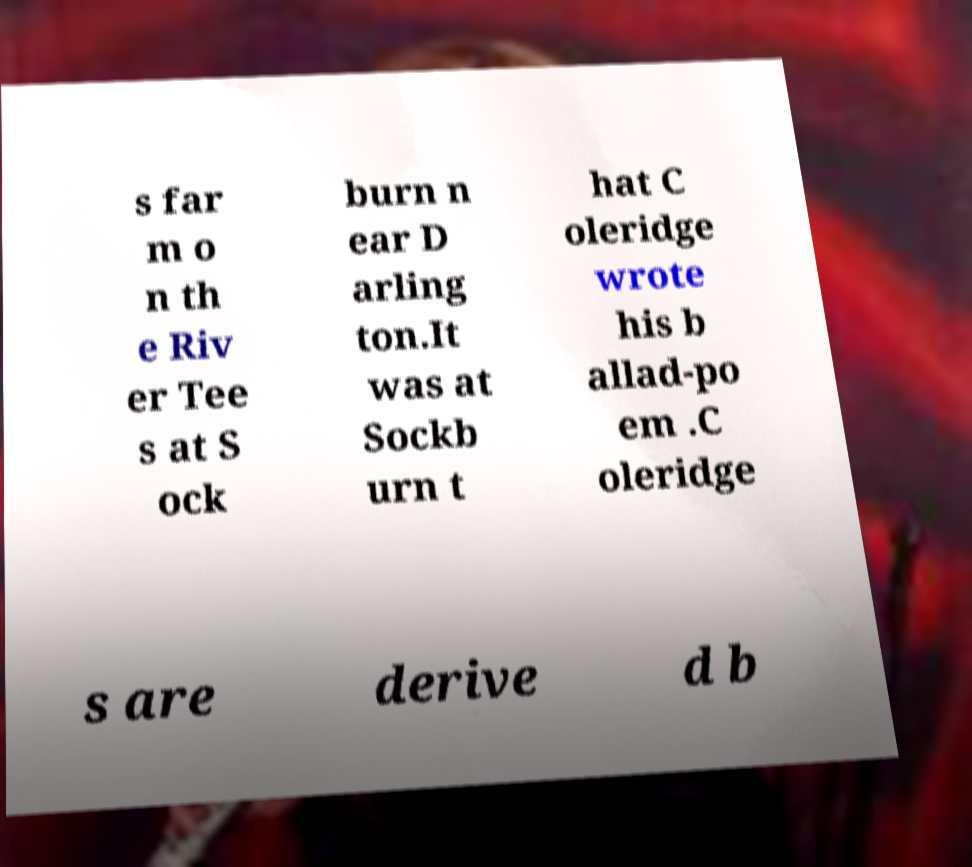Could you assist in decoding the text presented in this image and type it out clearly? s far m o n th e Riv er Tee s at S ock burn n ear D arling ton.It was at Sockb urn t hat C oleridge wrote his b allad-po em .C oleridge s are derive d b 